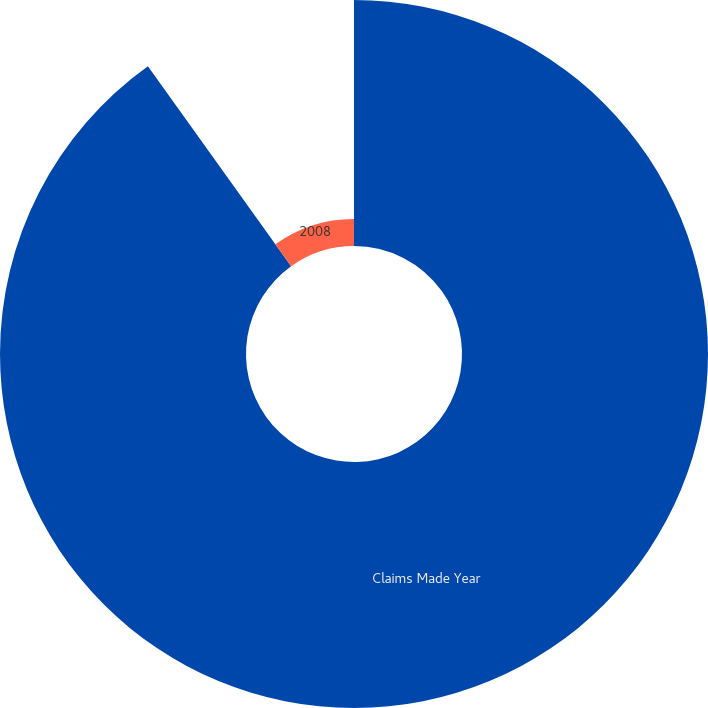Convert chart. <chart><loc_0><loc_0><loc_500><loc_500><pie_chart><fcel>Claims Made Year<fcel>2008<nl><fcel>90.11%<fcel>9.89%<nl></chart> 